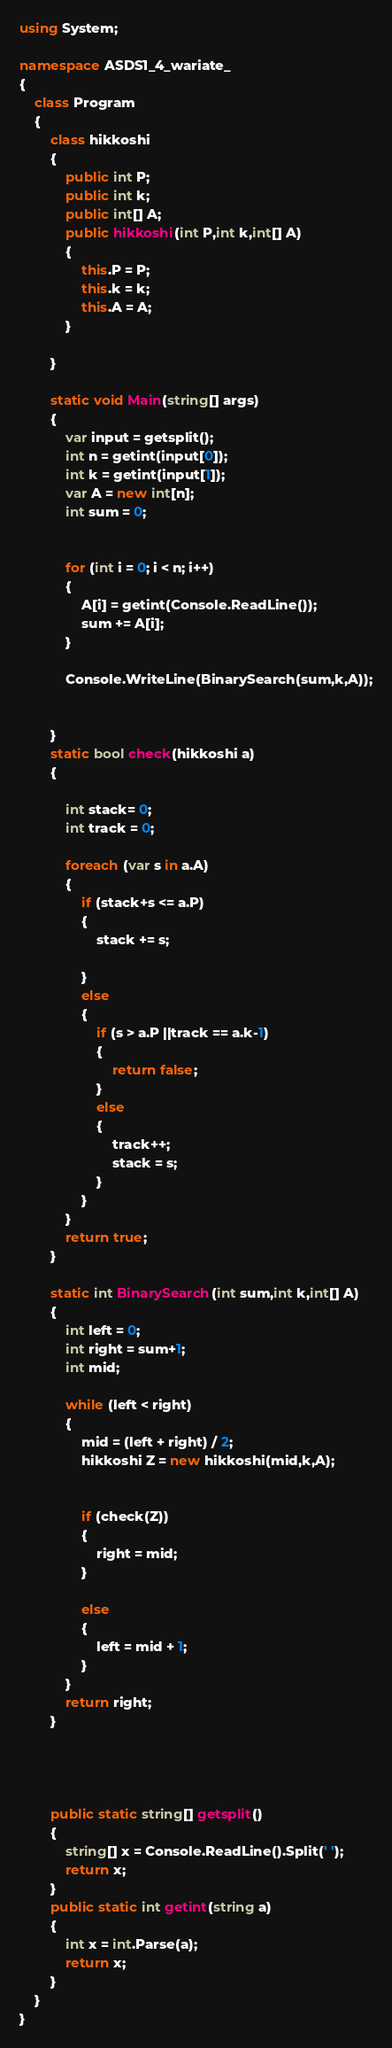Convert code to text. <code><loc_0><loc_0><loc_500><loc_500><_C#_>using System;

namespace ASDS1_4_wariate_
{
    class Program
    {
        class hikkoshi
        {
            public int P;
            public int k;
            public int[] A;
            public hikkoshi(int P,int k,int[] A)
            {
                this.P = P;
                this.k = k;
                this.A = A;
            }

        }

        static void Main(string[] args)
        {
            var input = getsplit();
            int n = getint(input[0]);
            int k = getint(input[1]);
            var A = new int[n];
            int sum = 0;
           

            for (int i = 0; i < n; i++)
            {
                A[i] = getint(Console.ReadLine());
                sum += A[i];
            }

            Console.WriteLine(BinarySearch(sum,k,A));


        }
        static bool check(hikkoshi a)
        {
            
            int stack= 0;
            int track = 0;

            foreach (var s in a.A)
            {
                if (stack+s <= a.P)
                {
                    stack += s;
                   
                }
                else
                {
                    if (s > a.P ||track == a.k-1)
                    {
                        return false;
                    }
                    else
                    {
                        track++;
                        stack = s;
                    }
                }
            }
            return true;
        }

        static int BinarySearch(int sum,int k,int[] A)
        {
            int left = 0;
            int right = sum+1;
            int mid;

            while (left < right)
            {
                mid = (left + right) / 2;
                hikkoshi Z = new hikkoshi(mid,k,A);
              

                if (check(Z))
                {
                    right = mid;
                }
                
                else
                {
                    left = mid + 1;
                }
            }
            return right;
        }




        public static string[] getsplit()
        {
            string[] x = Console.ReadLine().Split(' ');
            return x;
        }
        public static int getint(string a)
        {
            int x = int.Parse(a);
            return x;
        }
    }
}</code> 